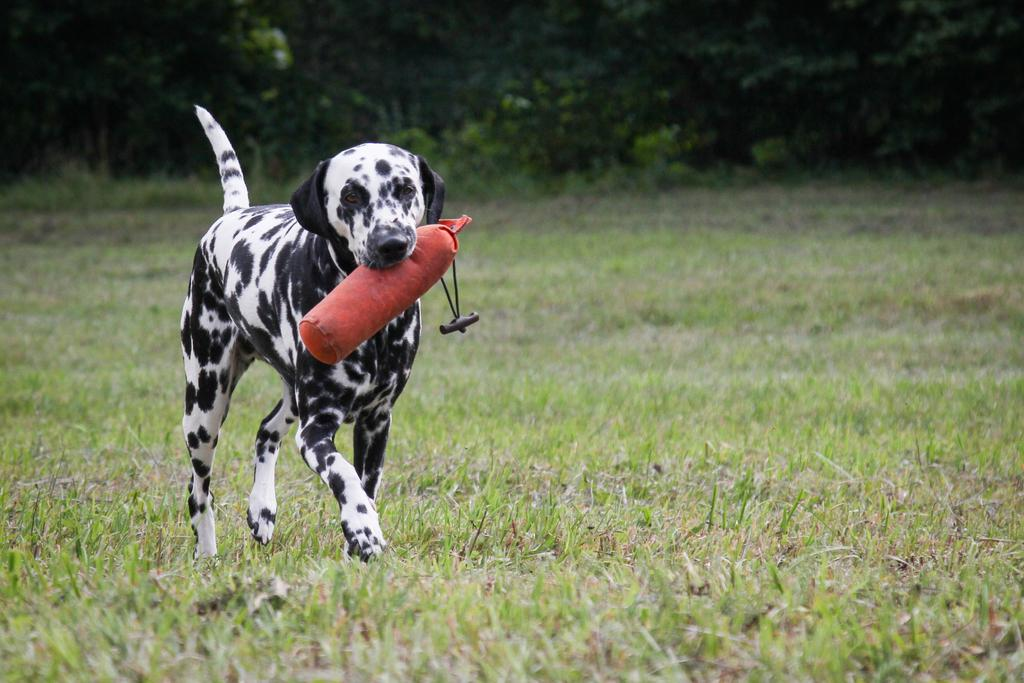What type of animal is present in the image? There is a dog in the image. What is the dog doing with its mouth? The dog is holding an object in its mouth. Where is the dog walking? The dog is walking on the grass. What can be seen in the background of the image? There are plants and trees in the background of the image. How many passengers are visible in the image? There are no passengers present in the image; it features a dog walking on the grass. What type of distribution is being carried out in the image? There is no distribution being carried out in the image; it features a dog holding an object in its mouth and walking on the grass. 